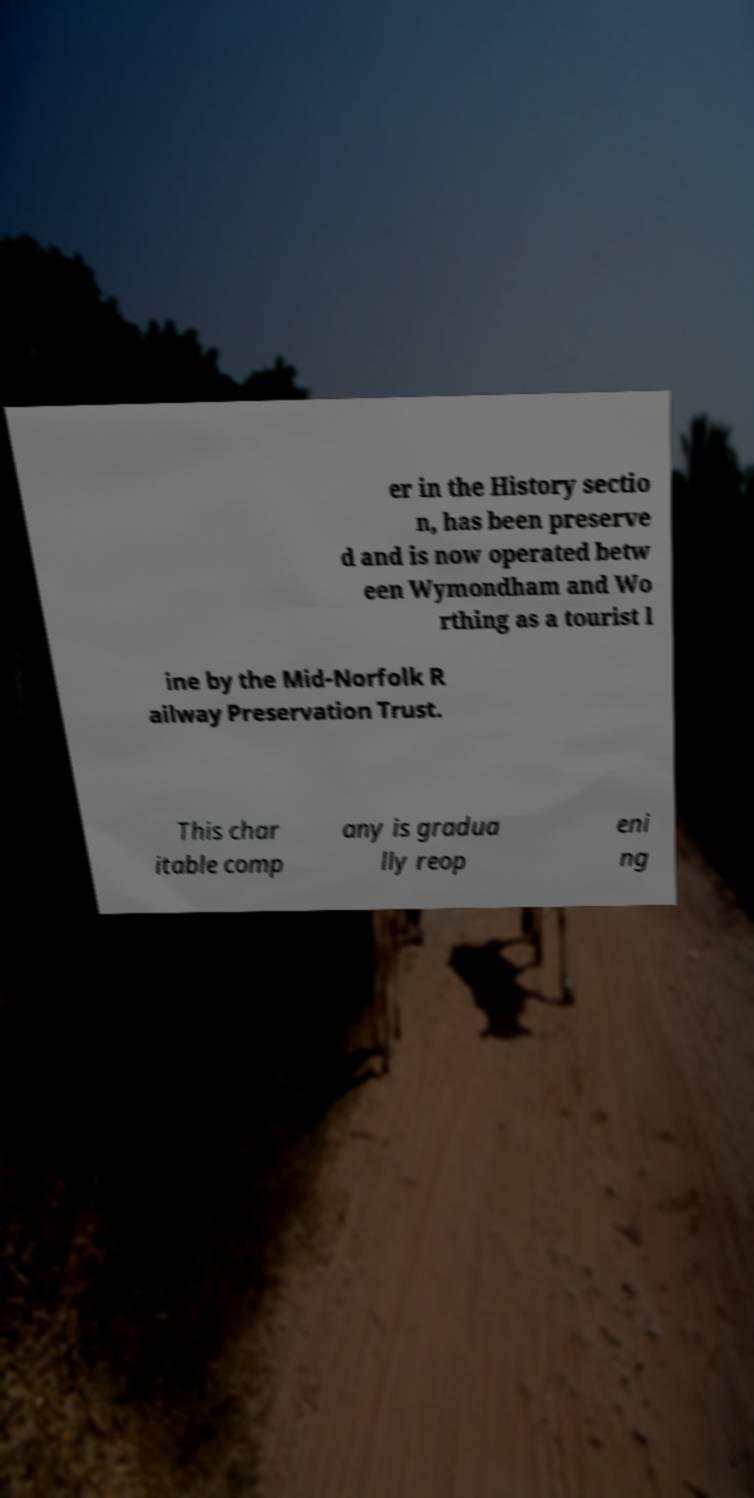Can you accurately transcribe the text from the provided image for me? er in the History sectio n, has been preserve d and is now operated betw een Wymondham and Wo rthing as a tourist l ine by the Mid-Norfolk R ailway Preservation Trust. This char itable comp any is gradua lly reop eni ng 